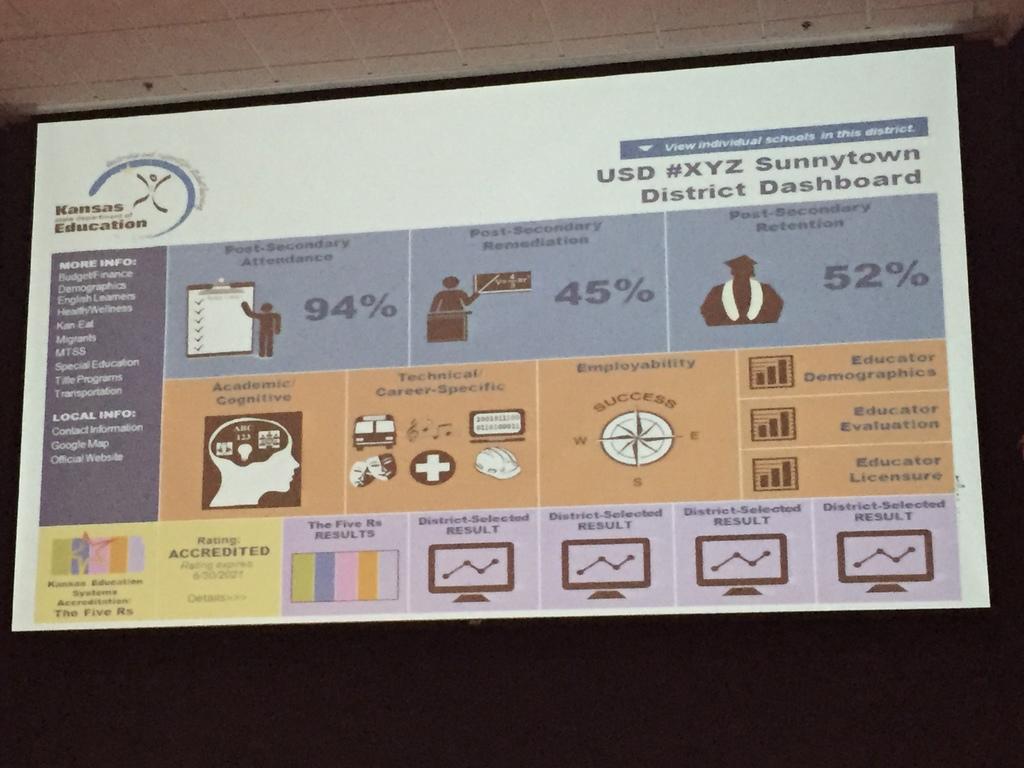What does that sign say?
Offer a very short reply. Unanswerable. What city is this from?
Make the answer very short. Sunnytown. 